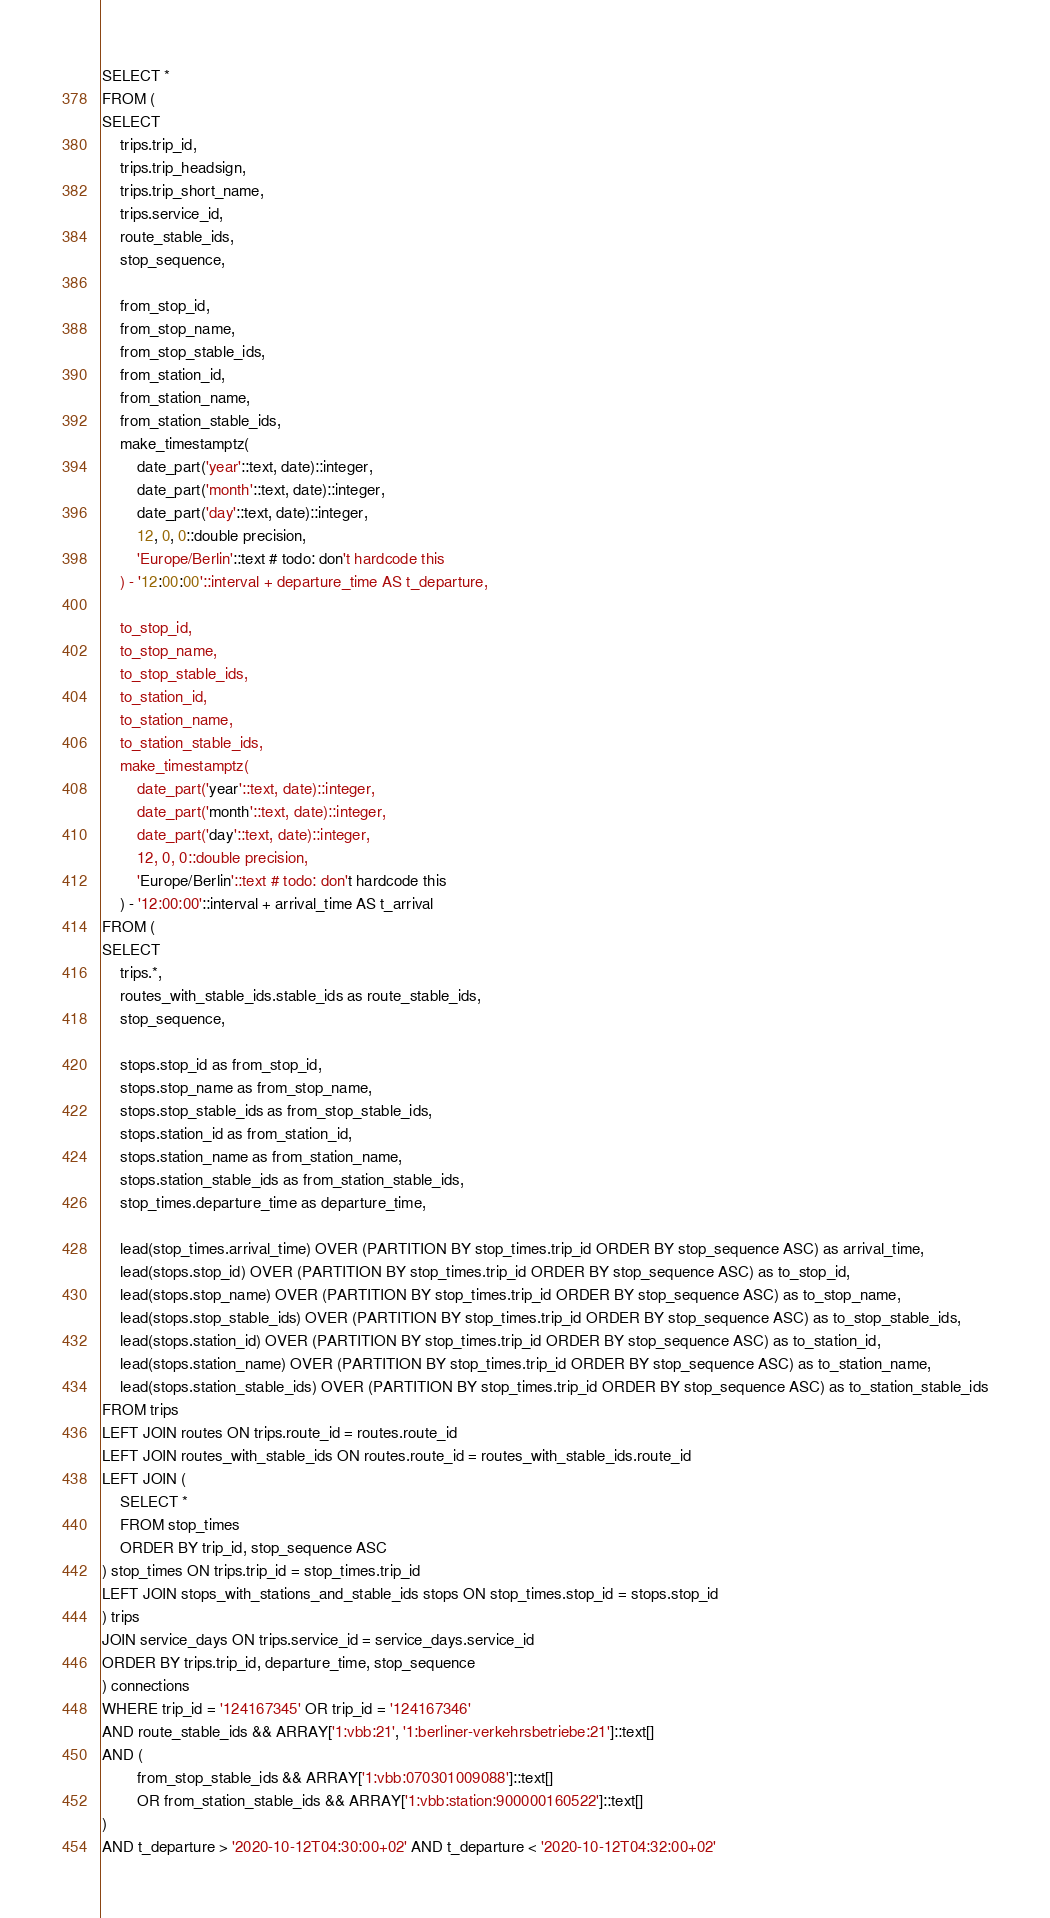Convert code to text. <code><loc_0><loc_0><loc_500><loc_500><_SQL_>SELECT *
FROM (
SELECT
	trips.trip_id,
	trips.trip_headsign,
	trips.trip_short_name,
	trips.service_id,
	route_stable_ids,
	stop_sequence,

	from_stop_id,
	from_stop_name,
	from_stop_stable_ids,
	from_station_id,
	from_station_name,
	from_station_stable_ids,
    make_timestamptz(
    	date_part('year'::text, date)::integer,
    	date_part('month'::text, date)::integer,
    	date_part('day'::text, date)::integer,
    	12, 0, 0::double precision,
    	'Europe/Berlin'::text # todo: don't hardcode this
    ) - '12:00:00'::interval + departure_time AS t_departure,

	to_stop_id,
	to_stop_name,
	to_stop_stable_ids,
	to_station_id,
	to_station_name,
	to_station_stable_ids,
    make_timestamptz(
    	date_part('year'::text, date)::integer,
    	date_part('month'::text, date)::integer,
    	date_part('day'::text, date)::integer,
    	12, 0, 0::double precision,
    	'Europe/Berlin'::text # todo: don't hardcode this
    ) - '12:00:00'::interval + arrival_time AS t_arrival
FROM (
SELECT
	trips.*,
	routes_with_stable_ids.stable_ids as route_stable_ids,
	stop_sequence,

	stops.stop_id as from_stop_id,
	stops.stop_name as from_stop_name,
	stops.stop_stable_ids as from_stop_stable_ids,
	stops.station_id as from_station_id,
	stops.station_name as from_station_name,
	stops.station_stable_ids as from_station_stable_ids,
	stop_times.departure_time as departure_time,

	lead(stop_times.arrival_time) OVER (PARTITION BY stop_times.trip_id ORDER BY stop_sequence ASC) as arrival_time,
	lead(stops.stop_id) OVER (PARTITION BY stop_times.trip_id ORDER BY stop_sequence ASC) as to_stop_id,
	lead(stops.stop_name) OVER (PARTITION BY stop_times.trip_id ORDER BY stop_sequence ASC) as to_stop_name,
	lead(stops.stop_stable_ids) OVER (PARTITION BY stop_times.trip_id ORDER BY stop_sequence ASC) as to_stop_stable_ids,
	lead(stops.station_id) OVER (PARTITION BY stop_times.trip_id ORDER BY stop_sequence ASC) as to_station_id,
	lead(stops.station_name) OVER (PARTITION BY stop_times.trip_id ORDER BY stop_sequence ASC) as to_station_name,
	lead(stops.station_stable_ids) OVER (PARTITION BY stop_times.trip_id ORDER BY stop_sequence ASC) as to_station_stable_ids
FROM trips
LEFT JOIN routes ON trips.route_id = routes.route_id
LEFT JOIN routes_with_stable_ids ON routes.route_id = routes_with_stable_ids.route_id
LEFT JOIN (
	SELECT *
	FROM stop_times
	ORDER BY trip_id, stop_sequence ASC
) stop_times ON trips.trip_id = stop_times.trip_id
LEFT JOIN stops_with_stations_and_stable_ids stops ON stop_times.stop_id = stops.stop_id
) trips
JOIN service_days ON trips.service_id = service_days.service_id
ORDER BY trips.trip_id, departure_time, stop_sequence
) connections
WHERE trip_id = '124167345' OR trip_id = '124167346'
AND route_stable_ids && ARRAY['1:vbb:21', '1:berliner-verkehrsbetriebe:21']::text[]
AND (
		from_stop_stable_ids && ARRAY['1:vbb:070301009088']::text[]
		OR from_station_stable_ids && ARRAY['1:vbb:station:900000160522']::text[]
)
AND t_departure > '2020-10-12T04:30:00+02' AND t_departure < '2020-10-12T04:32:00+02'
</code> 